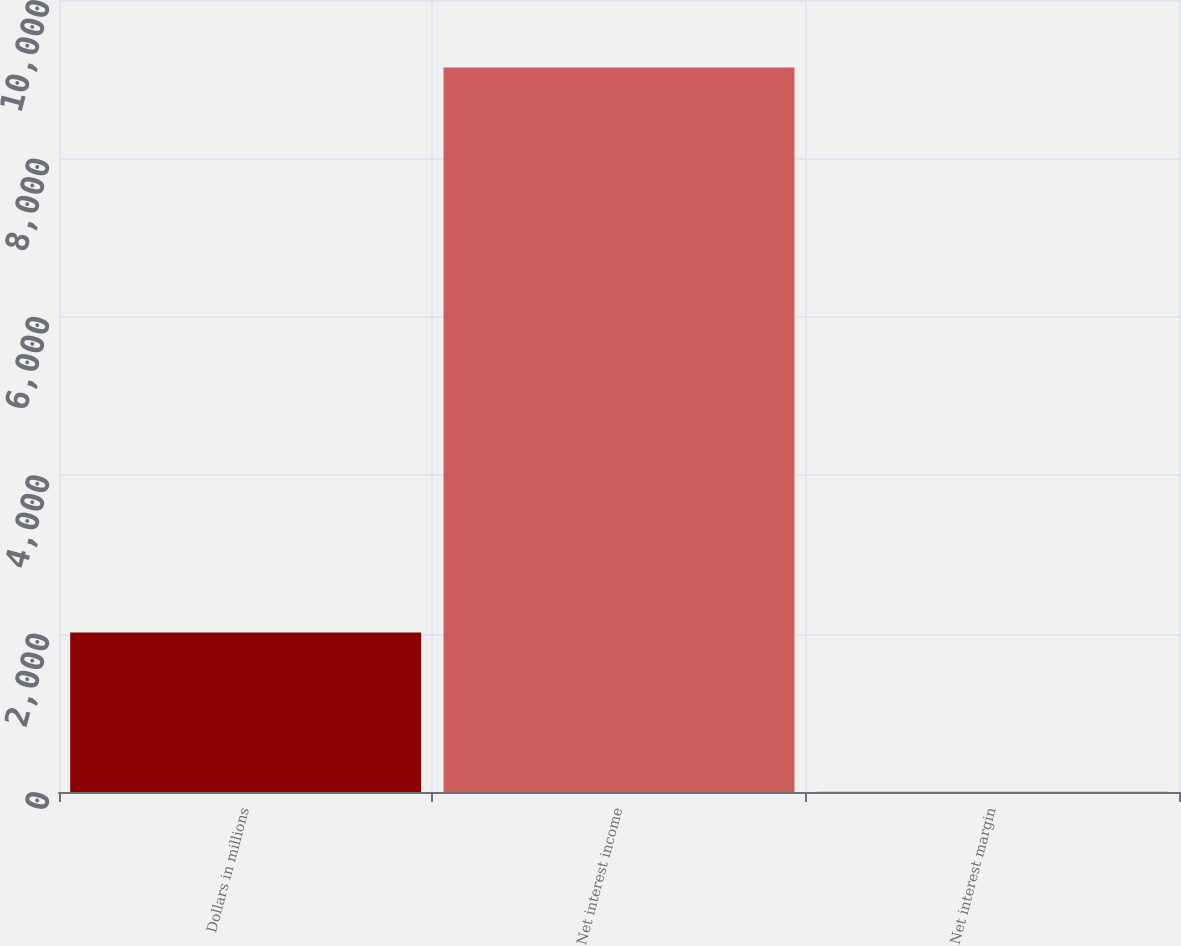<chart> <loc_0><loc_0><loc_500><loc_500><bar_chart><fcel>Dollars in millions<fcel>Net interest income<fcel>Net interest margin<nl><fcel>2013<fcel>9147<fcel>3.57<nl></chart> 